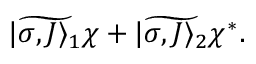<formula> <loc_0><loc_0><loc_500><loc_500>\widetilde { | \sigma , J \rangle _ { 1 } } \chi + \widetilde { | \sigma , J \rangle _ { 2 } } \chi ^ { * } .</formula> 